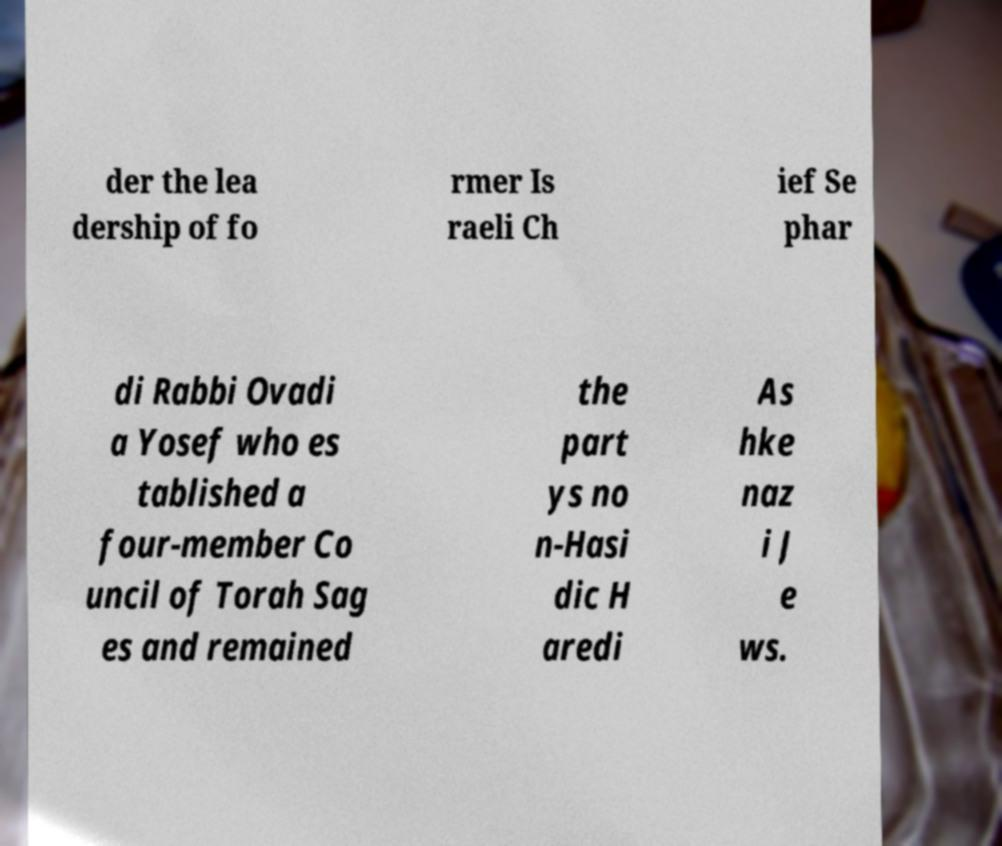Can you read and provide the text displayed in the image?This photo seems to have some interesting text. Can you extract and type it out for me? der the lea dership of fo rmer Is raeli Ch ief Se phar di Rabbi Ovadi a Yosef who es tablished a four-member Co uncil of Torah Sag es and remained the part ys no n-Hasi dic H aredi As hke naz i J e ws. 